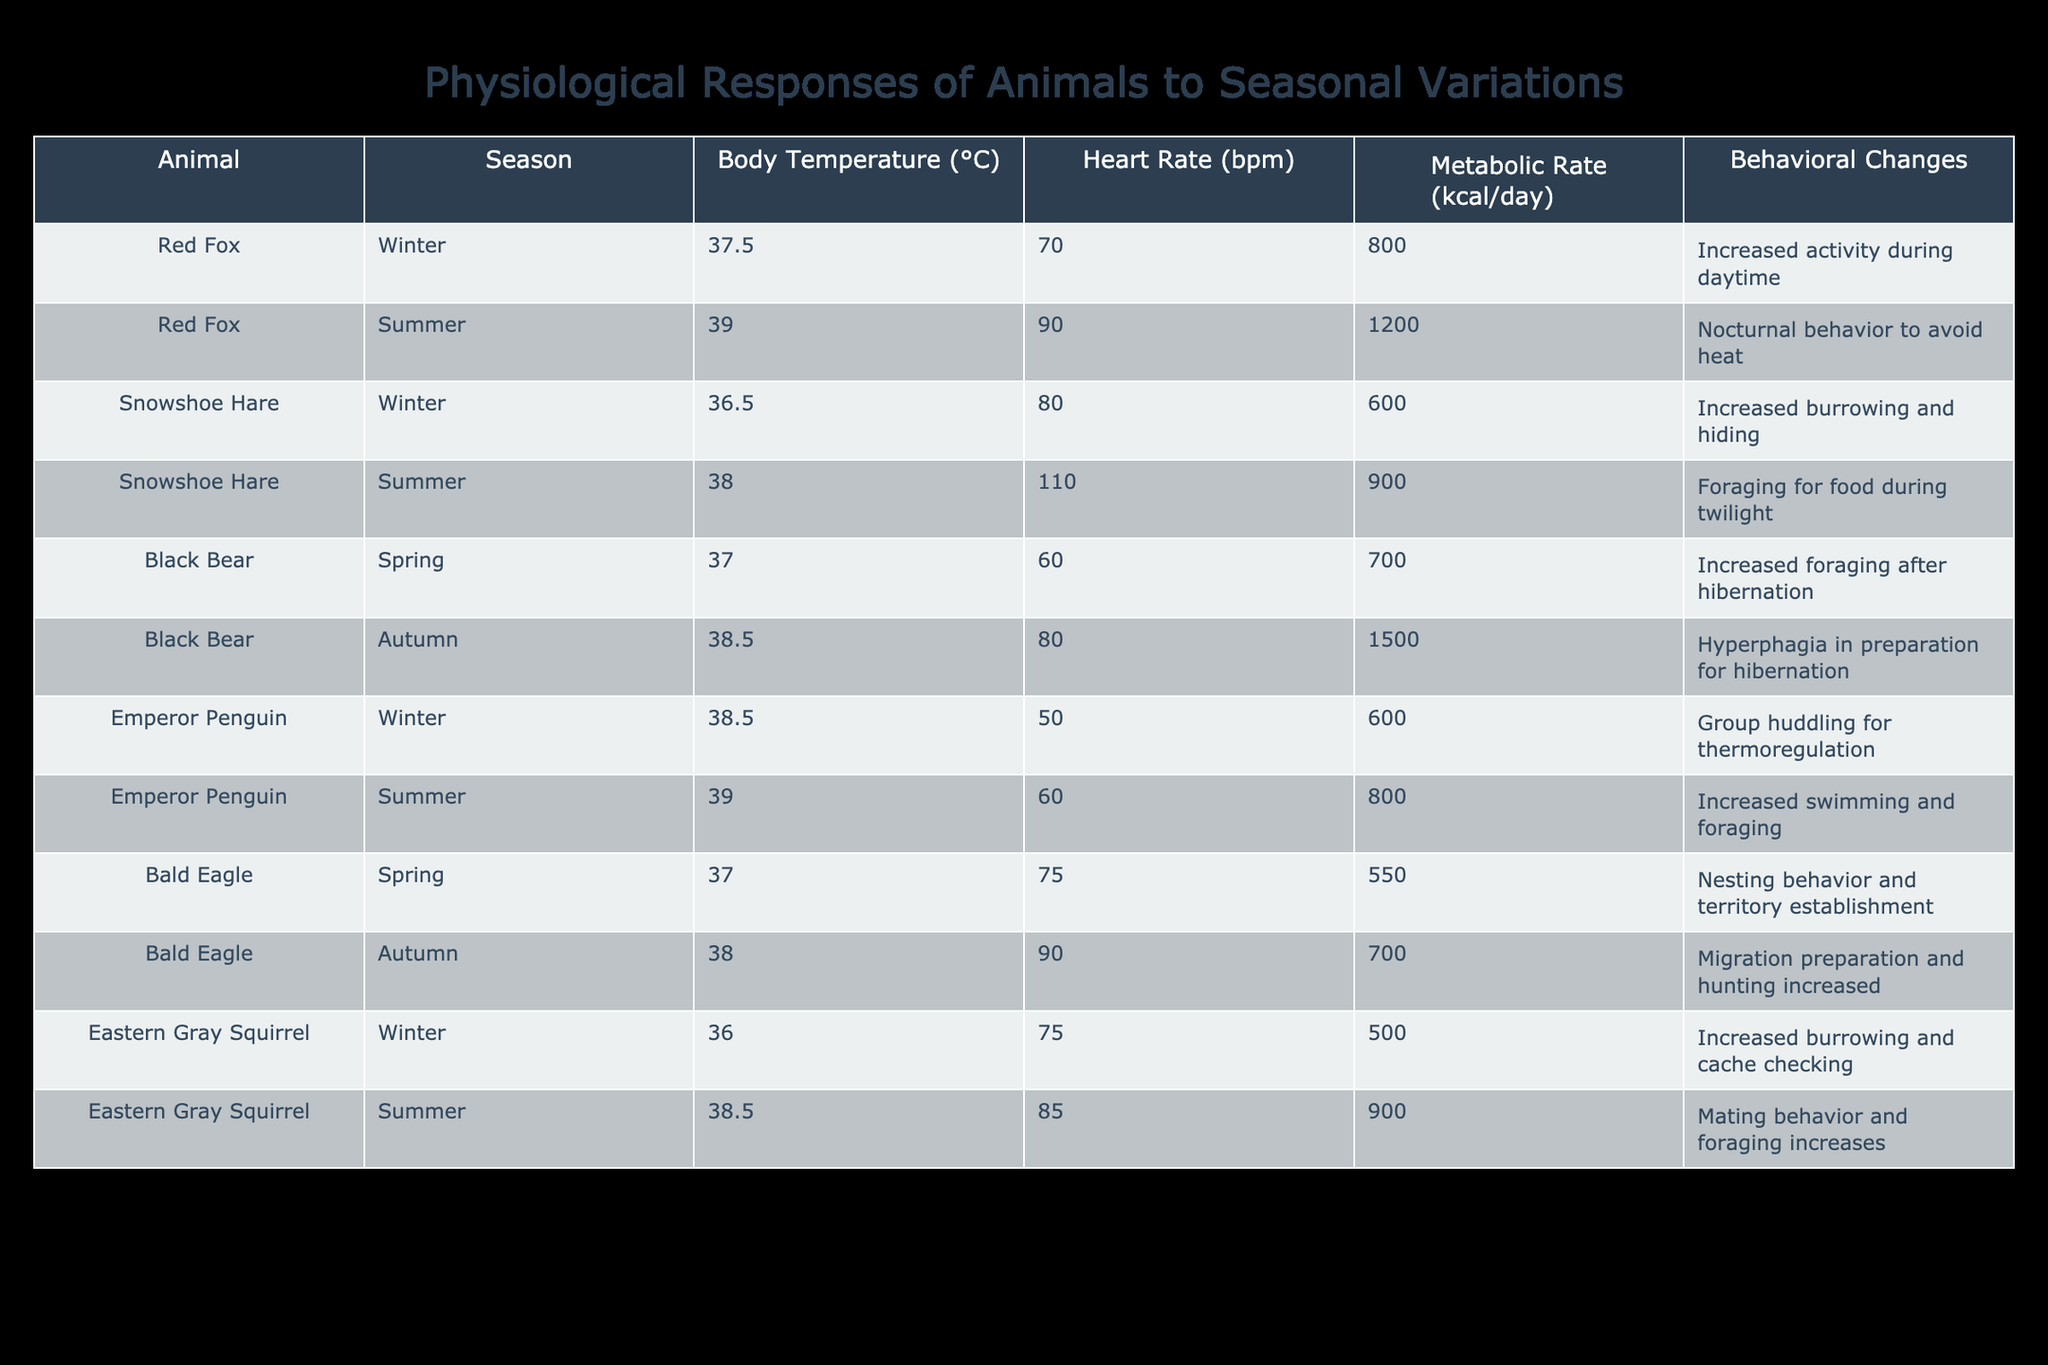What is the body temperature of the Snowshoe Hare in summer? The table indicates that the body temperature of the Snowshoe Hare during summer is 38.0 °C.
Answer: 38.0 °C How many kcal/day does the Black Bear consume in autumn? According to the table, the Black Bear's metabolic rate in autumn is 1500 kcal/day.
Answer: 1500 kcal/day Is the heart rate of the Emperor Penguin higher in winter or summer? The heart rate of the Emperor Penguin is lower in winter (50 bpm) compared to summer (60 bpm). Thus, summer has a higher heart rate.
Answer: Summer What is the difference in metabolic rate (kcal/day) between the Red Fox in summer and the Snowshoe Hare in winter? The Red Fox's metabolic rate in summer is 1200 kcal/day, while the Snowshoe Hare’s in winter is 600 kcal/day. The difference is 1200 - 600 = 600 kcal/day.
Answer: 600 kcal/day What animal has the lowest body temperature in winter, and what is that temperature? Examining the winter data, the Eastern Gray Squirrel has the lowest body temperature at 36.0 °C.
Answer: Eastern Gray Squirrel, 36.0 °C What average heart rate do the Bald Eagle and Black Bear have in spring? The Bald Eagle's heart rate in spring is 75 bpm, and the Black Bear's is 60 bpm. The average is (75 + 60) / 2 = 67.5 bpm.
Answer: 67.5 bpm Does the Snowshoe Hare increase its heart rate during summer compared to winter? Yes, the table shows that the heart rate of the Snowshoe Hare increases from 80 bpm in winter to 110 bpm in summer.
Answer: Yes Which animal exhibits hyperphagia in autumn, and what does this behavior entail? The Black Bear exhibits hyperphagia in autumn, which involves increased food intake in preparation for hibernation.
Answer: Black Bear, increased food intake What is the combined metabolic rate of the Emperor Penguin in winter and the Eastern Gray Squirrel in summer? The Emperor Penguin's metabolic rate in winter is 600 kcal/day, and the Eastern Gray Squirrel's in summer is 900 kcal/day. The combined metabolic rate is 600 + 900 = 1500 kcal/day.
Answer: 1500 kcal/day 